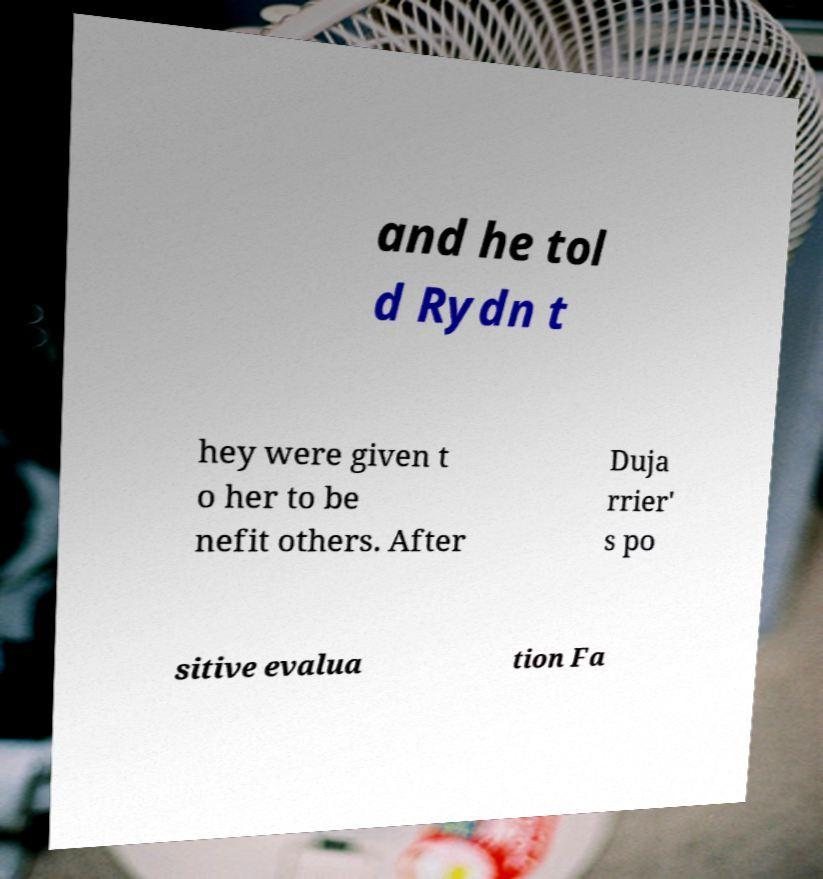Please read and relay the text visible in this image. What does it say? and he tol d Rydn t hey were given t o her to be nefit others. After Duja rrier' s po sitive evalua tion Fa 